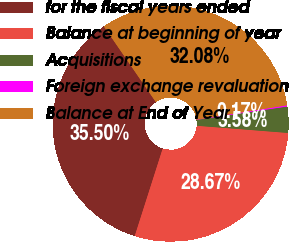Convert chart. <chart><loc_0><loc_0><loc_500><loc_500><pie_chart><fcel>for the fiscal years ended<fcel>Balance at beginning of year<fcel>Acquisitions<fcel>Foreign exchange revaluation<fcel>Balance at End of Year<nl><fcel>35.5%<fcel>28.67%<fcel>3.58%<fcel>0.17%<fcel>32.08%<nl></chart> 